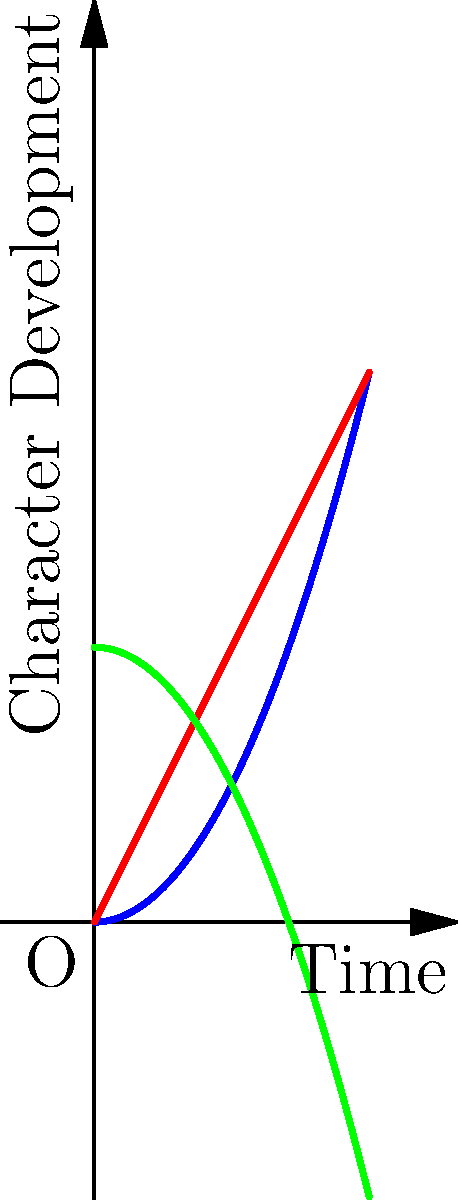In a children's novel, three characters' development arcs are plotted on a coordinate plane where the x-axis represents time and the y-axis represents character development. Character A's arc follows the function $f(x)=0.5x^2$, Character B's arc follows $g(x)=2x$, and Character C's arc follows $h(x)=4-0.5x^2$. At what point in time (x-coordinate) do Characters A and B have the same level of development? To find the point where Characters A and B have the same level of development, we need to find the intersection of their functions:

1) Set the functions equal to each other:
   $f(x) = g(x)$
   $0.5x^2 = 2x$

2) Rearrange the equation:
   $0.5x^2 - 2x = 0$

3) Factor out the common term:
   $x(0.5x - 2) = 0$

4) Solve for x:
   $x = 0$ or $0.5x - 2 = 0$
   $x = 0$ or $x = 4$

5) Since time cannot be negative in this context, and the graph shows positive development, we discard the $x = 0$ solution.

6) Therefore, Characters A and B have the same level of development when $x = 4$.

7) We can verify this by plugging $x = 4$ into both functions:
   $f(4) = 0.5(4)^2 = 8$
   $g(4) = 2(4) = 8$

Thus, at $x = 4$, both characters have a development level of 8.
Answer: $x = 4$ 